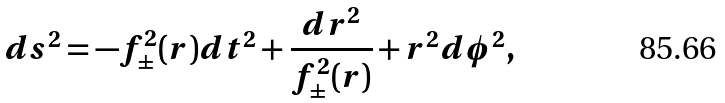<formula> <loc_0><loc_0><loc_500><loc_500>d s ^ { 2 } = - f _ { \pm } ^ { 2 } ( r ) d t ^ { 2 } + \frac { d r ^ { 2 } } { f _ { \pm } ^ { 2 } ( r ) } + r ^ { 2 } d \phi ^ { 2 } ,</formula> 